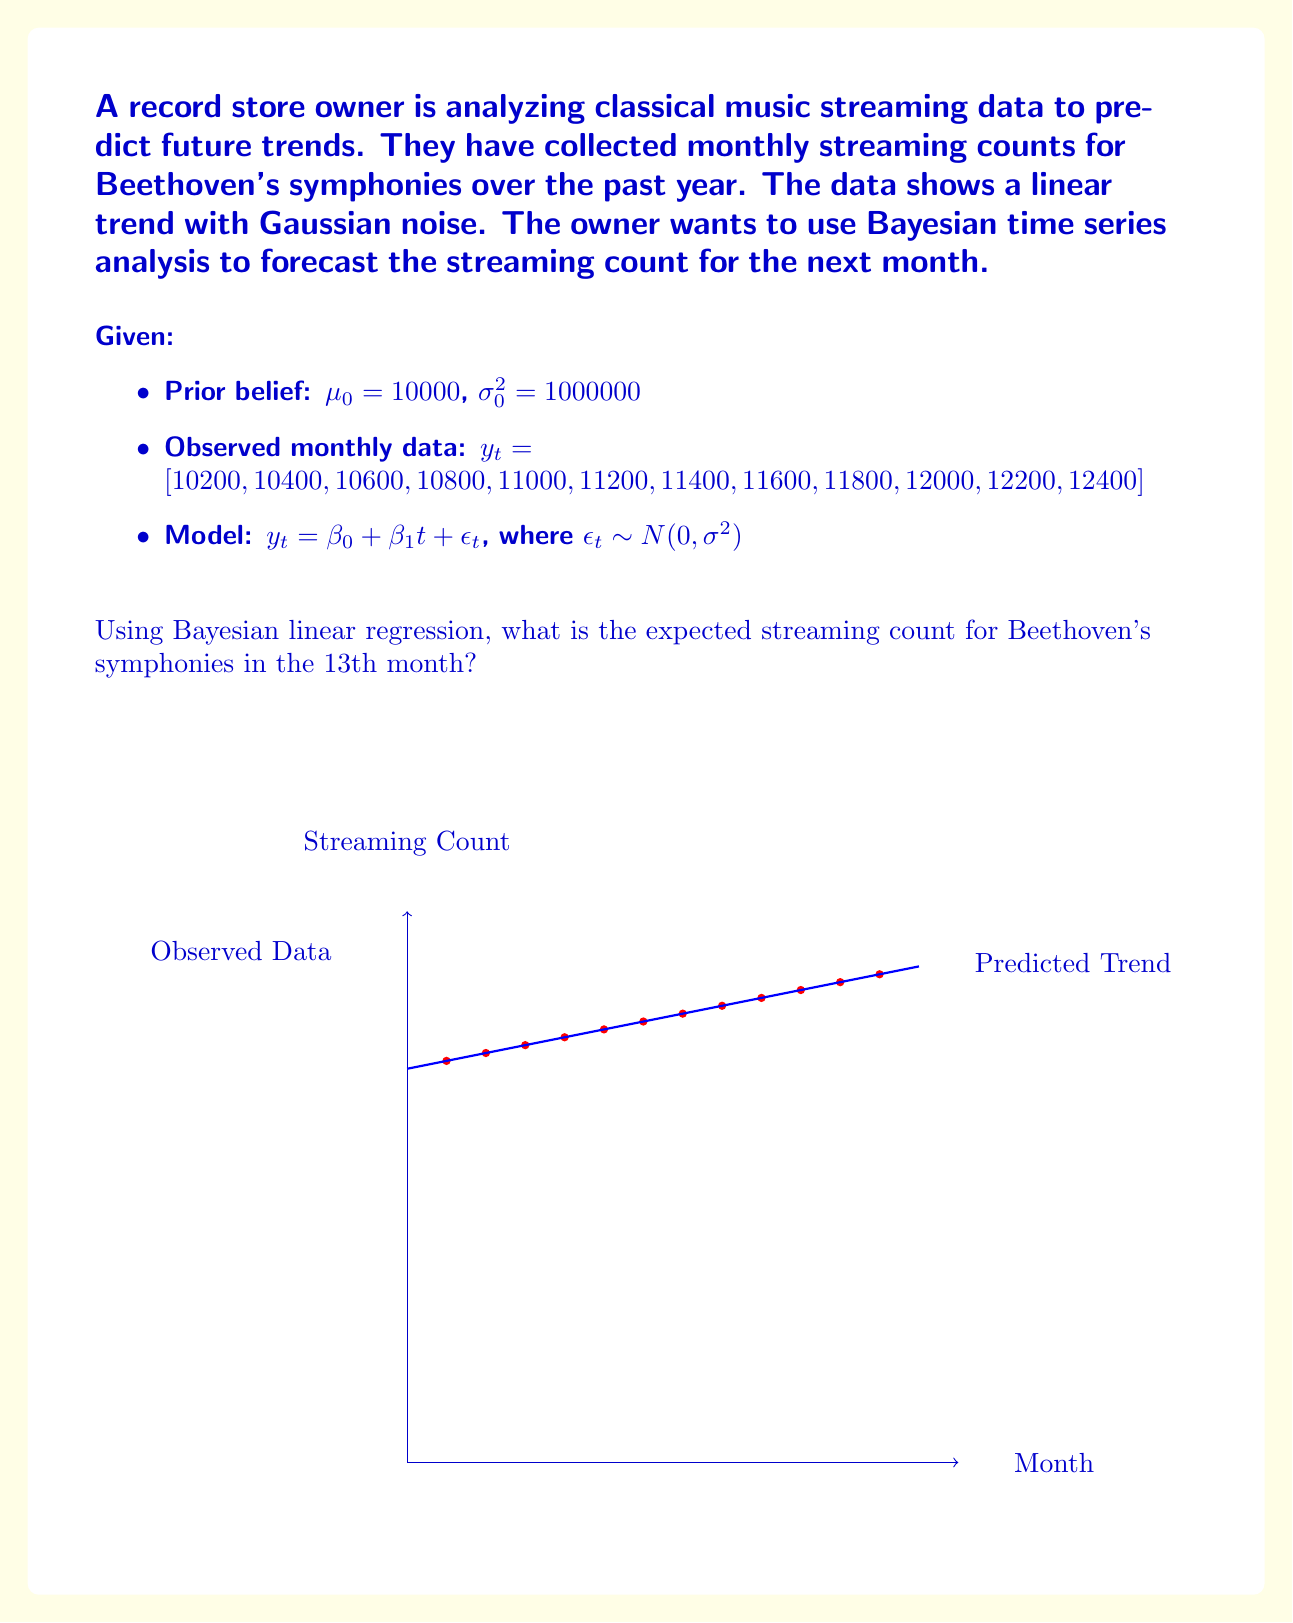Can you answer this question? To solve this problem using Bayesian linear regression, we'll follow these steps:

1) First, we need to calculate the ordinary least squares (OLS) estimates for $\beta_0$ and $\beta_1$:

   $\hat{\beta_1} = \frac{\sum_{i=1}^n (x_i - \bar{x})(y_i - \bar{y})}{\sum_{i=1}^n (x_i - \bar{x})^2}$
   $\hat{\beta_0} = \bar{y} - \hat{\beta_1}\bar{x}$

   Where $x_i$ are the months (1 to 12) and $y_i$ are the streaming counts.

2) Calculate $\bar{x}$ and $\bar{y}$:
   $\bar{x} = \frac{1+2+...+12}{12} = 6.5$
   $\bar{y} = \frac{10200+10400+...+12400}{12} = 11300$

3) Calculate $\hat{\beta_1}$ and $\hat{\beta_0}$:
   $\hat{\beta_1} = 200$ (the slope of the line)
   $\hat{\beta_0} = 11300 - 200(6.5) = 10000$

4) The OLS regression line is $y = 10000 + 200t$

5) Now, we need to update our prior beliefs using the observed data. The posterior distribution for $\beta$ is:

   $\beta | y \sim N(\beta_n, \Lambda_n^{-1})$

   Where:
   $\beta_n = \Lambda_n^{-1}(\Lambda_0\beta_0 + X^T\Sigma^{-1}y)$
   $\Lambda_n = \Lambda_0 + X^T\Sigma^{-1}X$

6) Given our prior $\mu_0 = 10000$ and $\sigma_0^2 = 1000000$, we can calculate $\beta_n$ and $\Lambda_n$.

7) The posterior predictive distribution for a new observation $y_{n+1}$ is:

   $y_{n+1} | y \sim N(X_{n+1}\beta_n, X_{n+1}\Lambda_n^{-1}X_{n+1}^T + \sigma^2)$

8) For the 13th month, $X_{n+1} = [1, 13]$

9) The expected value of $y_{13}$ is:

   $E[y_{13}] = X_{13}\beta_n = 10000 + 200(13) = 12600$

Therefore, the expected streaming count for Beethoven's symphonies in the 13th month is 12600.
Answer: 12600 